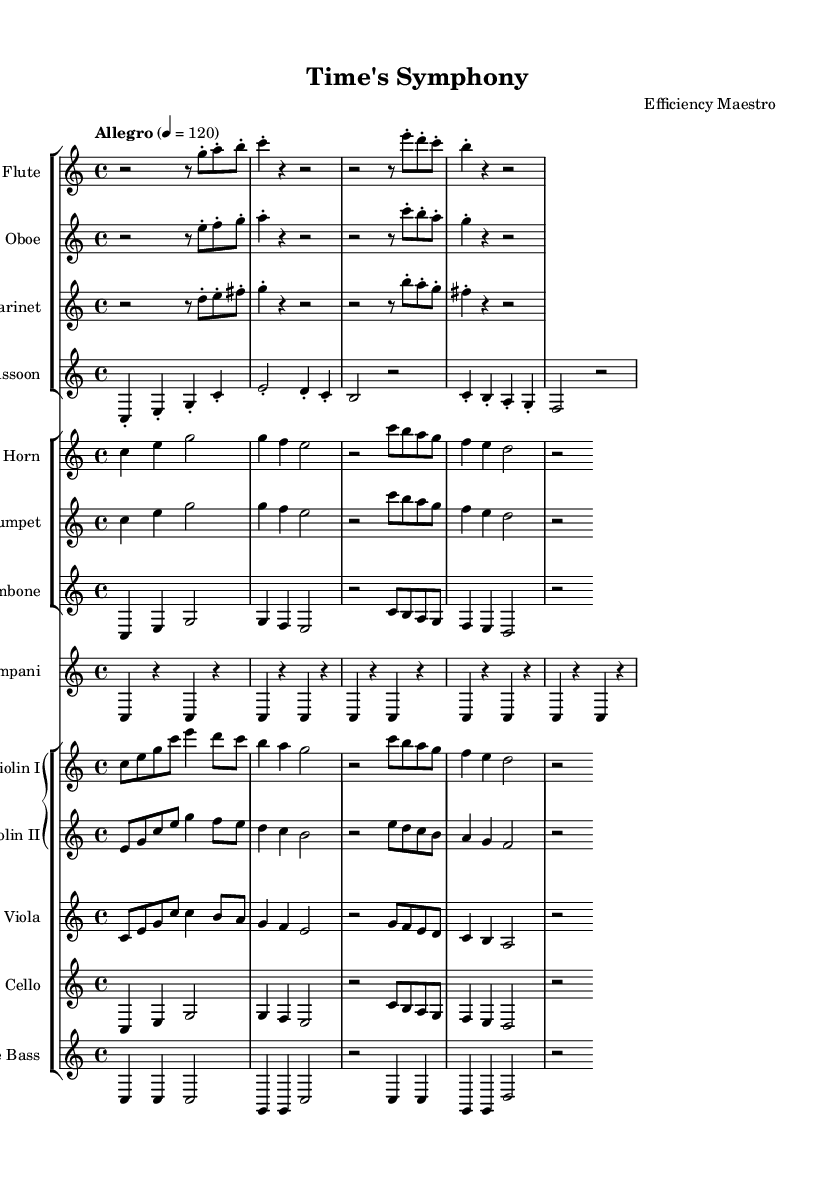What is the key signature of this music? The key signature is C major, which has no sharps or flats indicated on the sheet music. This can be identified from the beginning of the score where the key signature is shown.
Answer: C major What is the time signature of this music? The time signature shown at the beginning of the music is 4/4, which indicates that there are four beats in each measure and a quarter note receives one beat. It's clearly indicated at the start of the score.
Answer: 4/4 What is the tempo marking of this music? The tempo marking states "Allegro" with a metronome marking of 120, signifying a fast tempo. This is also shown at the beginning of the score.
Answer: Allegro 4 = 120 How many bars does the flute part have in the first section? By analyzing the sheet music, the flute part has four bars in the first section of the score. Counting the measures visually confirms this.
Answer: 4 bars Which instruments are in the woodwind section? The woodwind section consists of the Flute, Oboe, Clarinet, and Bassoon, as indicated by their respective staves in the orchestration.
Answer: Flute, Oboe, Clarinet, Bassoon Which instrument has a transposition indicated in the music? The Clarinet and Horn parts show transposition as indicated by "transposition" followed by the note they are transposed to (B flat for Clarinet and F for Horn) within their respective parts.
Answer: Clarinet, Horn What is the rhythmic pattern established by the timpani? The timpani part shows a steady pattern of alternating quarter rests and quarter notes, creating a consistent rhythmic foundation throughout the piece.
Answer: Alternating quarter notes and rests 